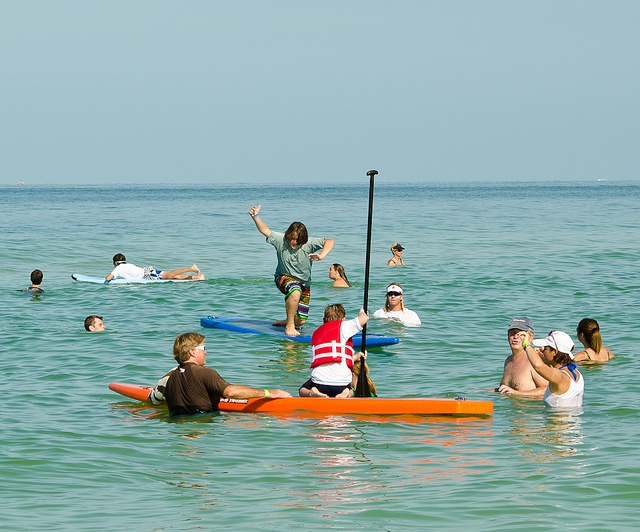Describe the objects in this image and their specific colors. I can see people in lightblue, black, maroon, and tan tones, surfboard in lightblue, red, orange, lightpink, and maroon tones, people in lightblue, white, red, black, and lightpink tones, people in lightblue, darkgray, black, and teal tones, and people in lightblue, white, tan, and black tones in this image. 